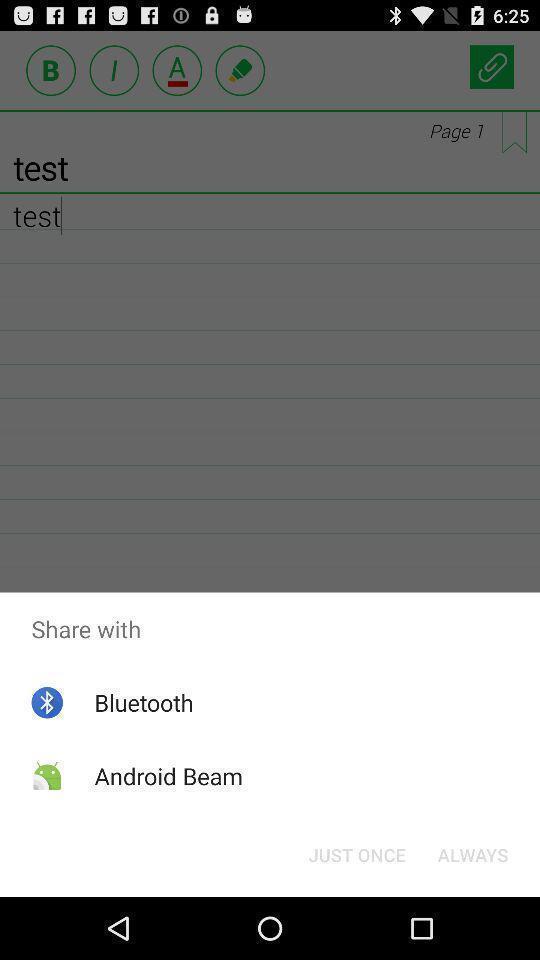Tell me about the visual elements in this screen capture. Pop-up showing different kind of sharing options. 